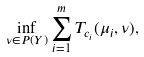<formula> <loc_0><loc_0><loc_500><loc_500>\inf _ { \nu \in P ( Y ) } \sum _ { i = 1 } ^ { m } T _ { c _ { i } } ( \mu _ { i } , \nu ) ,</formula> 